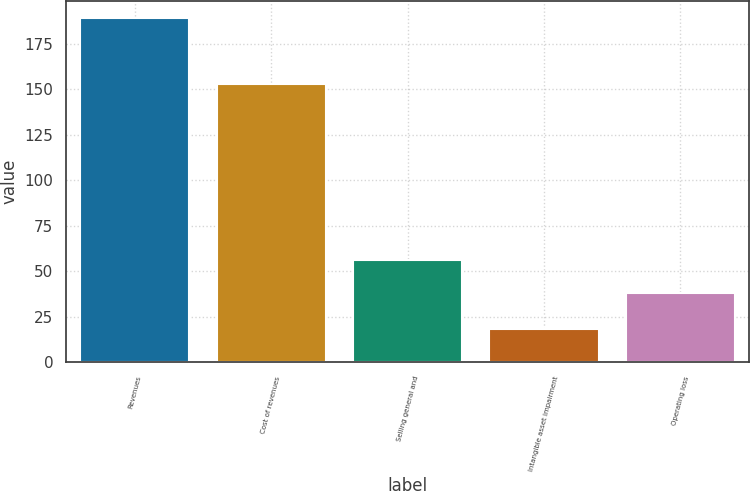Convert chart. <chart><loc_0><loc_0><loc_500><loc_500><bar_chart><fcel>Revenues<fcel>Cost of revenues<fcel>Selling general and<fcel>Intangible asset impairment<fcel>Operating loss<nl><fcel>189<fcel>153<fcel>56<fcel>18<fcel>38<nl></chart> 